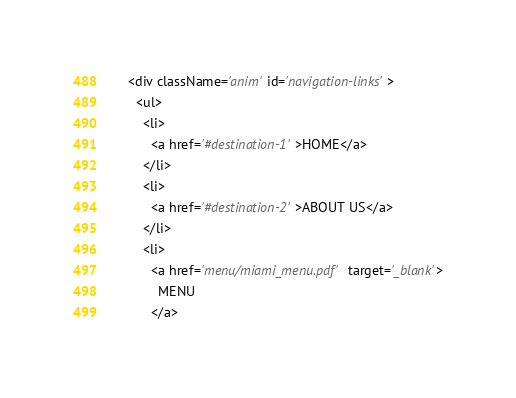<code> <loc_0><loc_0><loc_500><loc_500><_JavaScript_>
      <div className='anim' id='navigation-links'>
        <ul>
          <li>
            <a href='#destination-1'>HOME</a>
          </li>
          <li>
            <a href='#destination-2'>ABOUT US</a>
          </li>
          <li>
            <a href='menu/miami_menu.pdf' target='_blank'>
              MENU
            </a></code> 